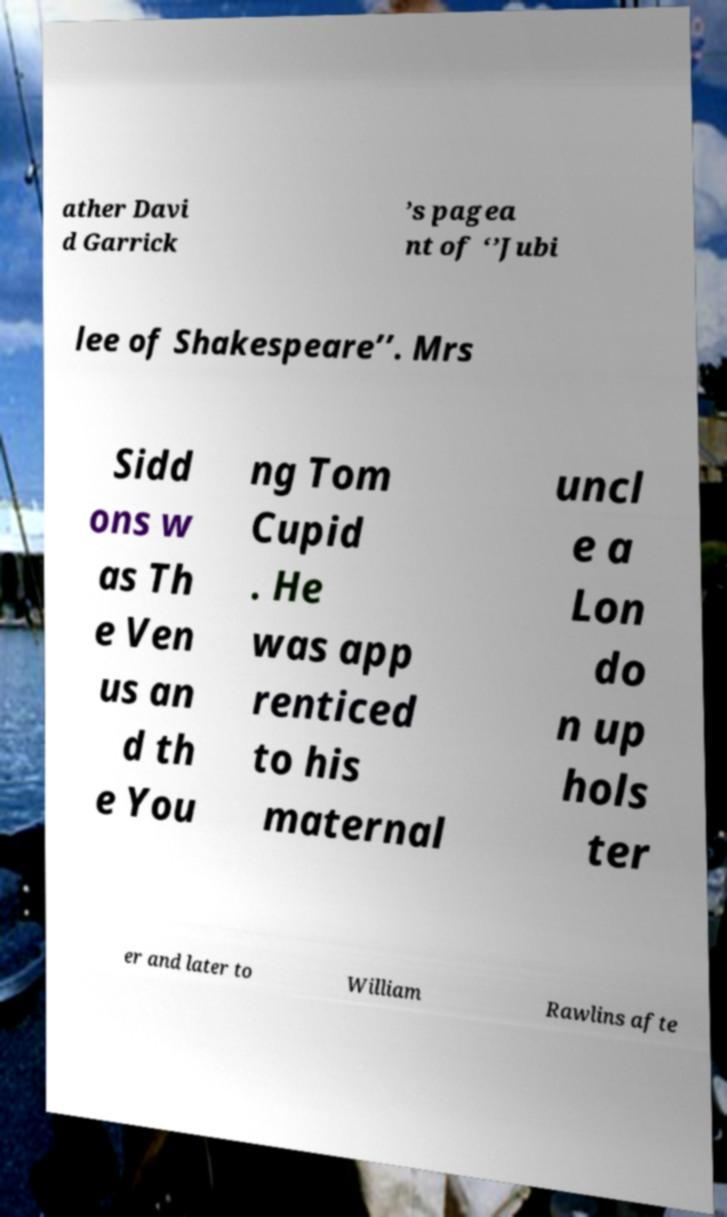There's text embedded in this image that I need extracted. Can you transcribe it verbatim? ather Davi d Garrick ’s pagea nt of ‘’Jubi lee of Shakespeare’’. Mrs Sidd ons w as Th e Ven us an d th e You ng Tom Cupid . He was app renticed to his maternal uncl e a Lon do n up hols ter er and later to William Rawlins afte 